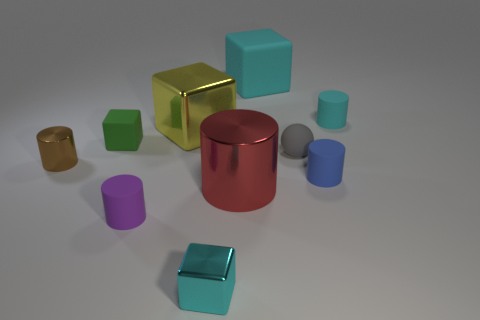Subtract all tiny brown cylinders. How many cylinders are left? 4 Subtract 2 cubes. How many cubes are left? 2 Subtract all cyan cylinders. How many cylinders are left? 4 Subtract all cubes. How many objects are left? 6 Add 4 large yellow cubes. How many large yellow cubes exist? 5 Subtract 0 blue blocks. How many objects are left? 10 Subtract all purple cubes. Subtract all blue spheres. How many cubes are left? 4 Subtract all purple balls. How many yellow blocks are left? 1 Subtract all tiny red rubber things. Subtract all yellow metallic things. How many objects are left? 9 Add 8 yellow cubes. How many yellow cubes are left? 9 